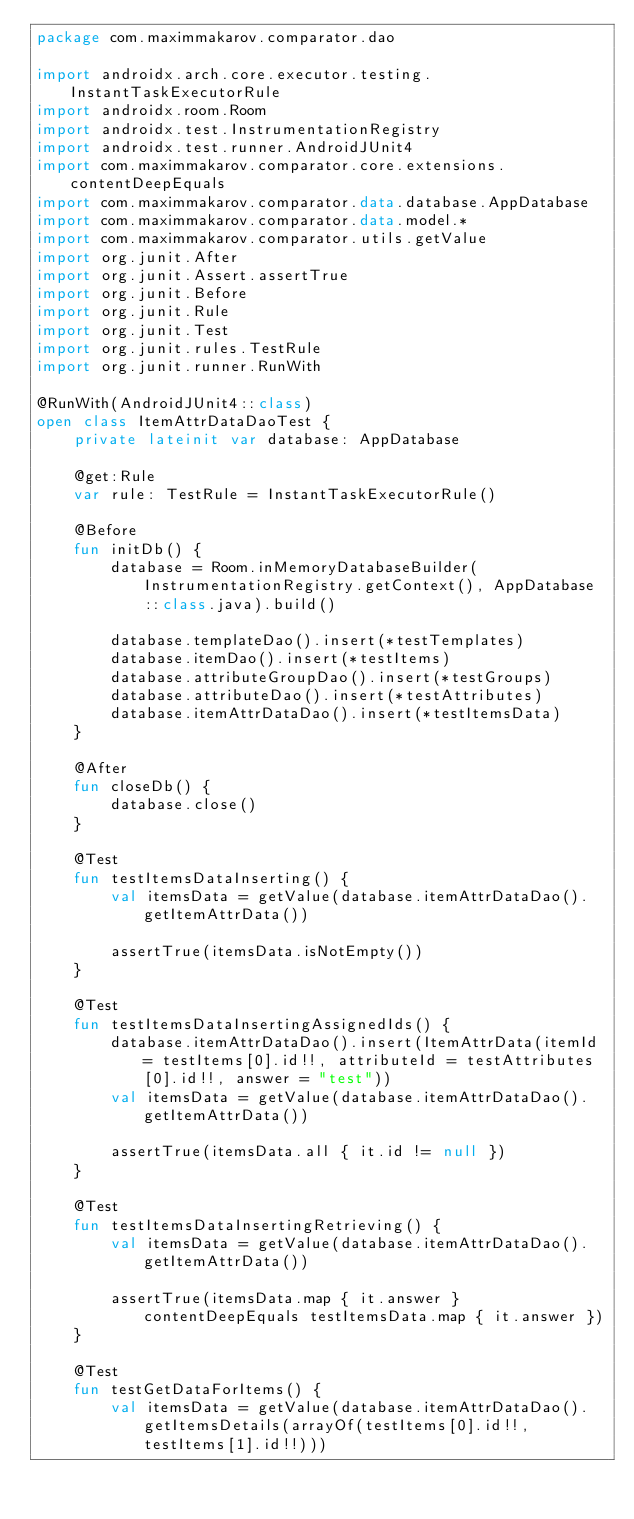Convert code to text. <code><loc_0><loc_0><loc_500><loc_500><_Kotlin_>package com.maximmakarov.comparator.dao

import androidx.arch.core.executor.testing.InstantTaskExecutorRule
import androidx.room.Room
import androidx.test.InstrumentationRegistry
import androidx.test.runner.AndroidJUnit4
import com.maximmakarov.comparator.core.extensions.contentDeepEquals
import com.maximmakarov.comparator.data.database.AppDatabase
import com.maximmakarov.comparator.data.model.*
import com.maximmakarov.comparator.utils.getValue
import org.junit.After
import org.junit.Assert.assertTrue
import org.junit.Before
import org.junit.Rule
import org.junit.Test
import org.junit.rules.TestRule
import org.junit.runner.RunWith

@RunWith(AndroidJUnit4::class)
open class ItemAttrDataDaoTest {
    private lateinit var database: AppDatabase

    @get:Rule
    var rule: TestRule = InstantTaskExecutorRule()

    @Before
    fun initDb() {
        database = Room.inMemoryDatabaseBuilder(InstrumentationRegistry.getContext(), AppDatabase::class.java).build()

        database.templateDao().insert(*testTemplates)
        database.itemDao().insert(*testItems)
        database.attributeGroupDao().insert(*testGroups)
        database.attributeDao().insert(*testAttributes)
        database.itemAttrDataDao().insert(*testItemsData)
    }

    @After
    fun closeDb() {
        database.close()
    }

    @Test
    fun testItemsDataInserting() {
        val itemsData = getValue(database.itemAttrDataDao().getItemAttrData())

        assertTrue(itemsData.isNotEmpty())
    }

    @Test
    fun testItemsDataInsertingAssignedIds() {
        database.itemAttrDataDao().insert(ItemAttrData(itemId = testItems[0].id!!, attributeId = testAttributes[0].id!!, answer = "test"))
        val itemsData = getValue(database.itemAttrDataDao().getItemAttrData())

        assertTrue(itemsData.all { it.id != null })
    }

    @Test
    fun testItemsDataInsertingRetrieving() {
        val itemsData = getValue(database.itemAttrDataDao().getItemAttrData())

        assertTrue(itemsData.map { it.answer } contentDeepEquals testItemsData.map { it.answer })
    }

    @Test
    fun testGetDataForItems() {
        val itemsData = getValue(database.itemAttrDataDao().getItemsDetails(arrayOf(testItems[0].id!!, testItems[1].id!!)))
</code> 